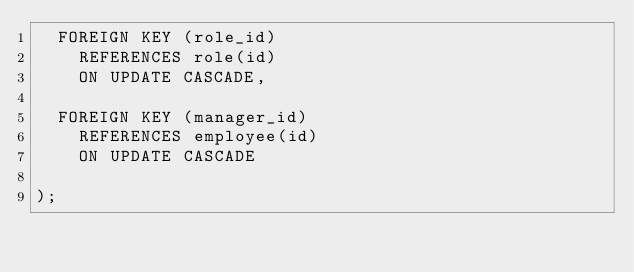Convert code to text. <code><loc_0><loc_0><loc_500><loc_500><_SQL_>  FOREIGN KEY (role_id)
    REFERENCES role(id)
    ON UPDATE CASCADE,

  FOREIGN KEY (manager_id)
    REFERENCES employee(id)
    ON UPDATE CASCADE
  
);



</code> 